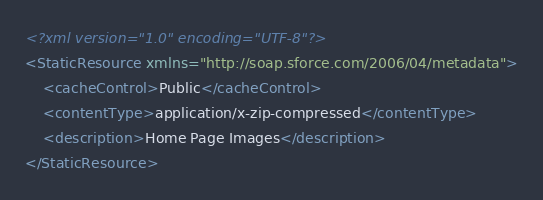Convert code to text. <code><loc_0><loc_0><loc_500><loc_500><_XML_><?xml version="1.0" encoding="UTF-8"?>
<StaticResource xmlns="http://soap.sforce.com/2006/04/metadata">
    <cacheControl>Public</cacheControl>
    <contentType>application/x-zip-compressed</contentType>
    <description>Home Page Images</description>
</StaticResource>
</code> 